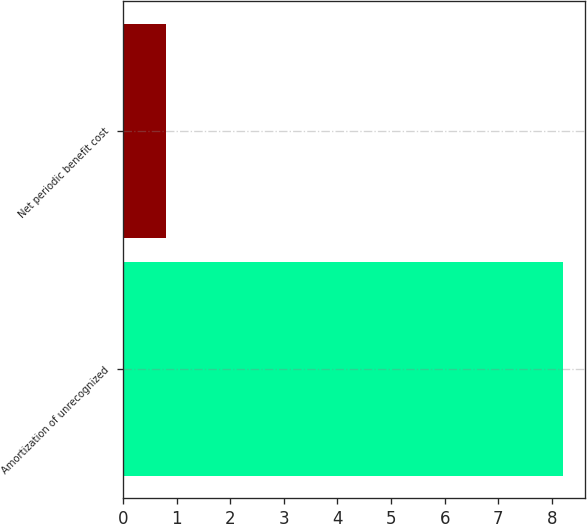<chart> <loc_0><loc_0><loc_500><loc_500><bar_chart><fcel>Amortization of unrecognized<fcel>Net periodic benefit cost<nl><fcel>8.2<fcel>0.8<nl></chart> 